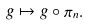Convert formula to latex. <formula><loc_0><loc_0><loc_500><loc_500>g \mapsto g \circ \pi _ { n } .</formula> 